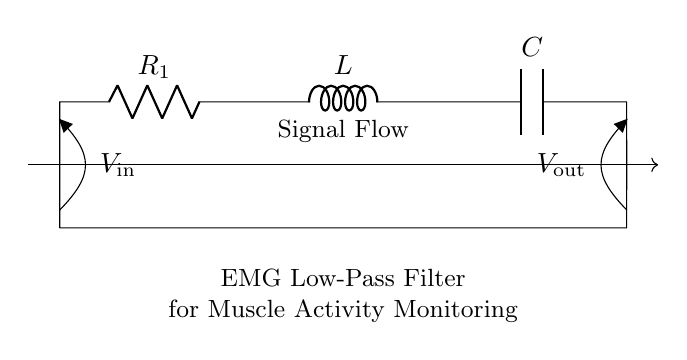What components are present in this circuit? The circuit includes a resistor, an inductor, and a capacitor, which are the essential components of an RLC circuit. This is evident from the labels R, L, and C placed in the diagram.
Answer: Resistor, Inductor, Capacitor What is the purpose of this circuit? The circuit is described as an EMG low-pass filter for muscle activity monitoring, highlighting its intended function in processing signals from electromyography sensors.
Answer: EMG Low-Pass Filter What is the input voltage labeled as? The input voltage is noted in the circuit diagram as V in, making it easy to identify in the visual representation.
Answer: V in What is the output voltage labeled as? The output voltage is clearly marked in the circuit as V out, directly indicating where the filtered signal can be measured after processing.
Answer: V out How many components are in series in this circuit? The circuit diagram shows all three components (the resistor, inductor, and capacitor) connected in series, demonstrating that they are part of a single path for current flow.
Answer: Three What type of filter is represented in this circuit? The combination of a resistor, inductor, and capacitor in this configuration suggests that it is a low-pass filter, designed to allow low-frequency signals to pass while attenuating high-frequency signals.
Answer: Low-Pass Filter What effect does the inductor have in this circuit? The inductor in this circuit introduces inductive reactance, which opposes changes in current, affecting the frequency response of the filter and allowing specific ranges of frequencies from the EMG signals to pass through.
Answer: Opposes change in current 